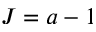Convert formula to latex. <formula><loc_0><loc_0><loc_500><loc_500>J = a - 1</formula> 